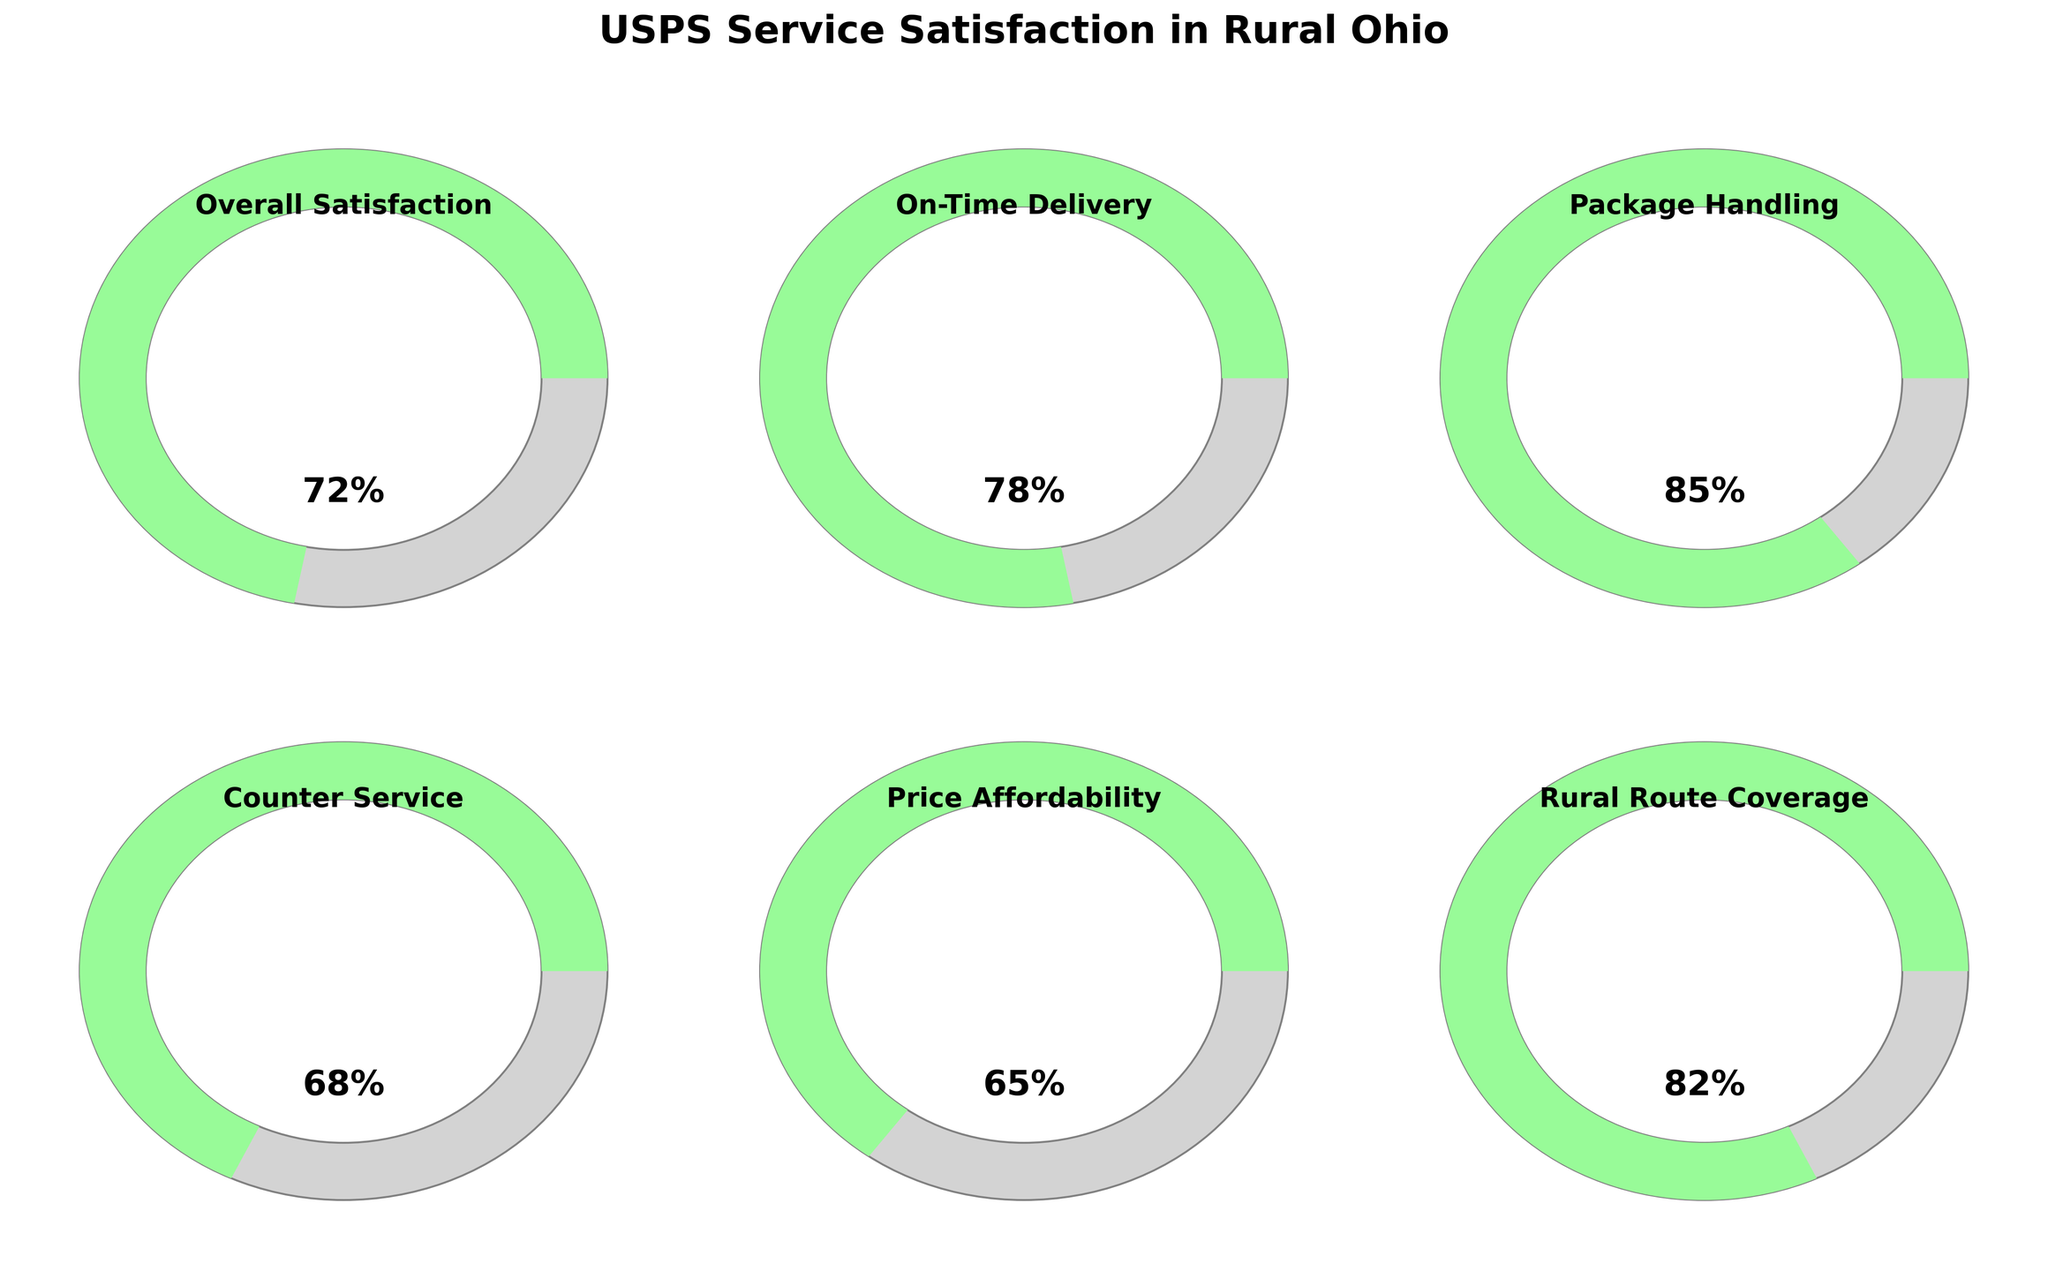What is the overall satisfaction level for USPS services in rural Ohio? The gauge chart shows a percentage labeled "Overall Satisfaction." The value is displayed as 72%.
Answer: 72% What percentage represents On-Time Delivery satisfaction? The gauge chart for "On-Time Delivery" indicates a value of 78%, as shown on the gauge meter.
Answer: 78% Which category has the highest satisfaction level? By comparing the values shown in each gauge, "Package Handling" has the highest satisfaction level at 85%.
Answer: Package Handling How does the satisfaction level of Price Affordability compare to Rural Route Coverage? The gauge chart for "Price Affordability" shows 65%, while "Rural Route Coverage" shows 82%. Therefore, "Rural Route Coverage" has a higher satisfaction percentage.
Answer: Higher What is the average satisfaction level across all categories? Adding the values of all categories: 72 (Overall Satisfaction) + 78 (On-Time Delivery) + 85 (Package Handling) + 68 (Counter Service) + 65 (Price Affordability) + 82 (Rural Route Coverage) = 450. Dividing by the number of categories (6), 450/6 = 75.
Answer: 75% Which satisfaction metrics fall below 70%? By examining the gauge values, "Counter Service" (68%) and "Price Affordability" (65%) are below 70%.
Answer: Counter Service, Price Affordability If the minimum satisfaction level required is 70%, how many categories currently meet this threshold? By checking the gauge values, "Overall Satisfaction" (72%), "On-Time Delivery" (78%), "Package Handling" (85%), and "Rural Route Coverage" (82%) all meet or exceed the 70% threshold.
Answer: 4 What's the difference between the highest and lowest satisfaction levels shown? The highest satisfaction level is for "Package Handling" at 85% and the lowest is "Price Affordability" at 65%. The difference is 85 - 65 = 20.
Answer: 20 How do the satisfaction levels of Counter Service and On-Time Delivery compare? The gauge chart shows "Counter Service" at 68% and "On-Time Delivery" at 78%. "On-Time Delivery" is higher.
Answer: On-Time Delivery is higher 